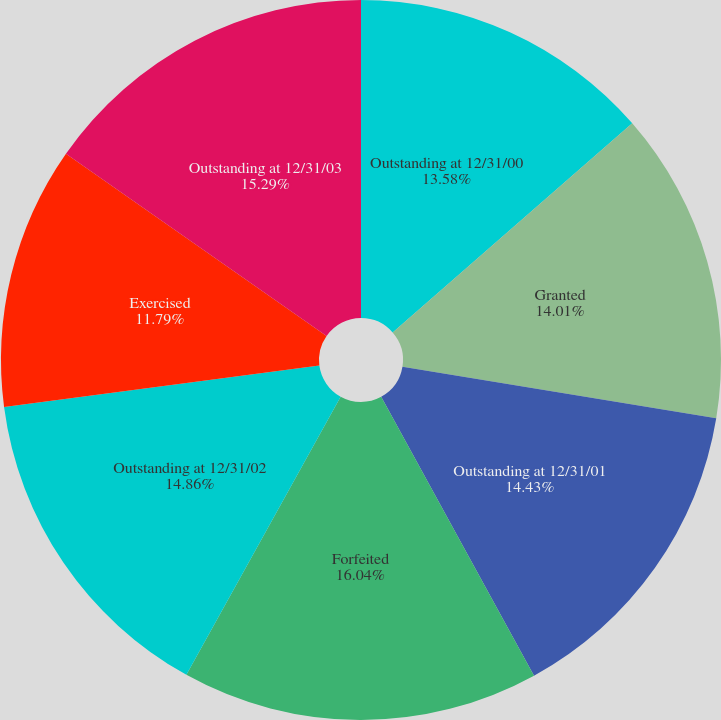Convert chart. <chart><loc_0><loc_0><loc_500><loc_500><pie_chart><fcel>Outstanding at 12/31/00<fcel>Granted<fcel>Outstanding at 12/31/01<fcel>Forfeited<fcel>Outstanding at 12/31/02<fcel>Exercised<fcel>Outstanding at 12/31/03<nl><fcel>13.58%<fcel>14.01%<fcel>14.43%<fcel>16.04%<fcel>14.86%<fcel>11.79%<fcel>15.29%<nl></chart> 